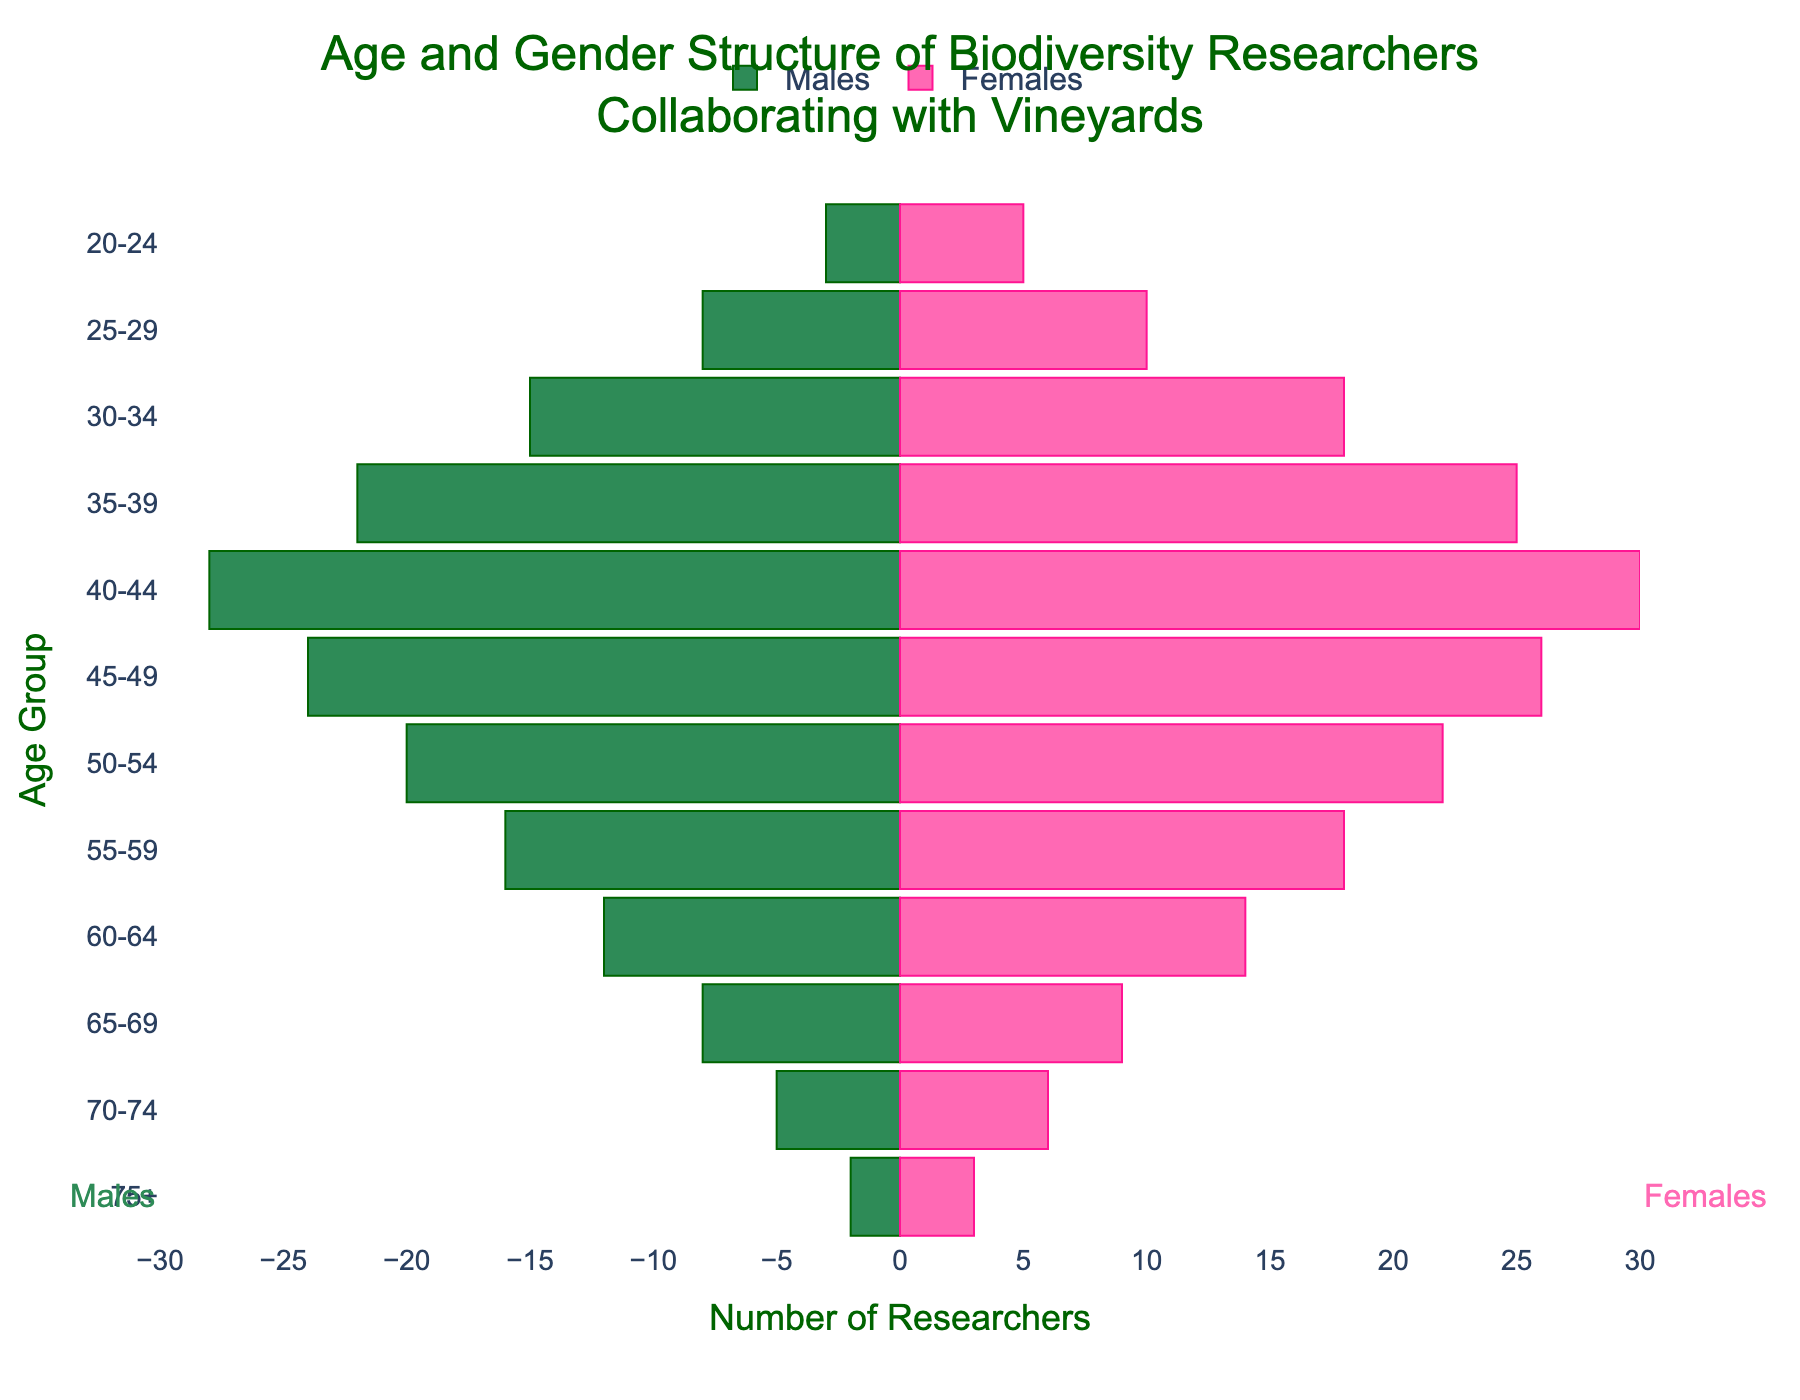What is the title of the figure? The title is located at the top of the figure and usually summarizes the content. From the code, the title is defined as 'Age and Gender Structure of Biodiversity Researchers Collaborating with Vineyards'.
Answer: Age and Gender Structure of Biodiversity Researchers Collaborating with Vineyards How many females are in the 30-34 age group? Locate the 30-34 age group and check the length of the female bar. From the data, the number of females is 18.
Answer: 18 Which age group has the highest number of male researchers? Look for the male bar that extends the farthest left, indicating the maximum value. The 40-44 age group has 28 males, which is the highest.
Answer: 40-44 What is the total number of researchers in the 50-54 age group? Sum the number of males and females in this age group: males (20) + females (22).
Answer: 42 Is there an age group where the number of female researchers surpasses the males by more than 4? Compare the numbers of males and females and find the differences for each age group. In the 20-24 age group, females (5) surpass males (3) by 2. In the 25-29 age group, females (10) surpass males (8) by 2. So, no age group has females surpassing males by more than 4.
Answer: No What is the overall trend in the number of researchers as age increases? Analyze the lengths of bars across different age groups from youngest to oldest. The number of researchers generally decreases as age increases.
Answer: Decreasing How many more researchers are there in the 35-39 age group compared to the 65-69 age group? Calculate the total researchers in each age group first: 35-39 (22 males + 25 females = 47), 65-69 (8 males + 9 females = 17), and then find the difference (47 - 17).
Answer: 30 In which age group do males and females have the closest numbers? Look for age groups where the male and female bars have similar lengths. In the 45-49 age group, males (24) and females (26) have a difference of only 2, which is the closest among all groups.
Answer: 45-49 How does the number of males in the 55-59 age group compare to the number of females in the 55-59 age group? Compare the lengths of the male and female bars for the 55-59 age group. There are 16 males and 18 females, so females outnumber males by 2.
Answer: Females outnumber males by 2 What is the gender ratio (males to females) in the age group 60-64? Divide the number of males by the number of females in this group: 12 males / 14 females = 0.857.
Answer: 0.857 